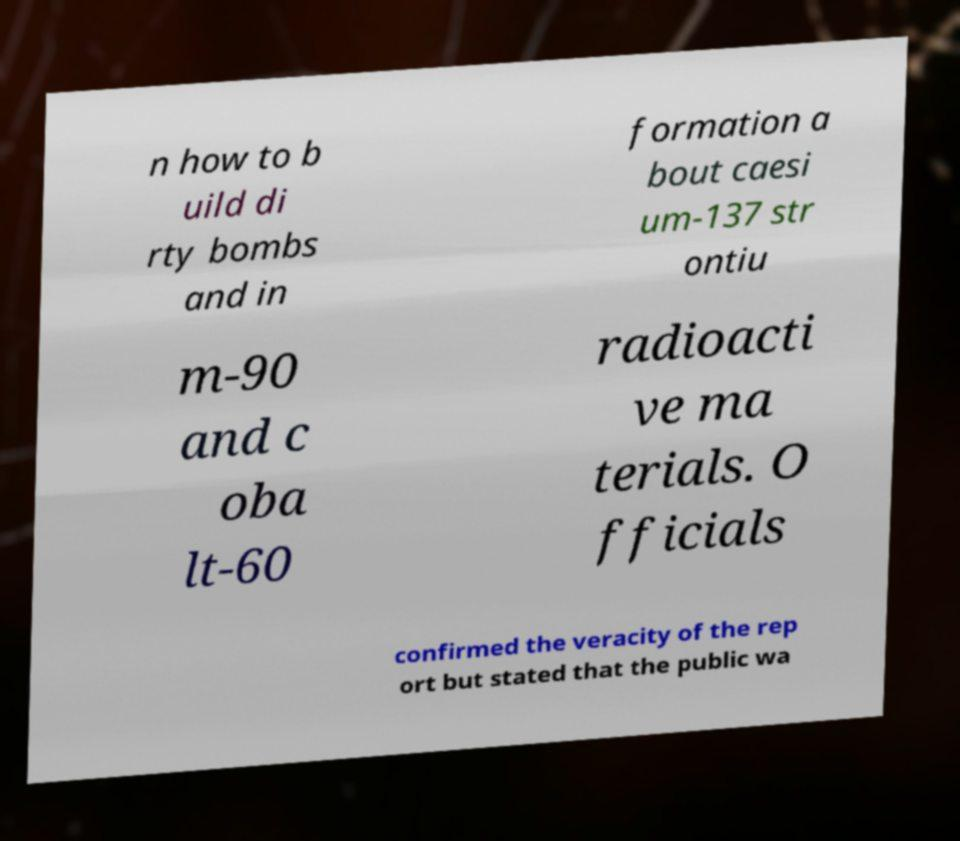Could you extract and type out the text from this image? n how to b uild di rty bombs and in formation a bout caesi um-137 str ontiu m-90 and c oba lt-60 radioacti ve ma terials. O fficials confirmed the veracity of the rep ort but stated that the public wa 